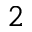Convert formula to latex. <formula><loc_0><loc_0><loc_500><loc_500>^ { 2 }</formula> 